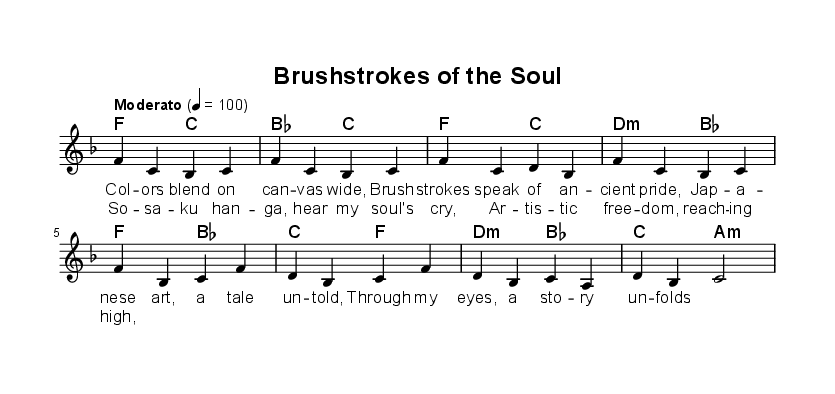what is the key signature of this music? The key signature indicated in the music is F major, which has one flat (B flat).
Answer: F major what is the time signature of this music? The time signature shown in the music is 4/4, indicating four beats per measure.
Answer: 4/4 what is the tempo marking of this piece? The tempo marking indicates "Moderato" at a speed of 100 beats per minute.
Answer: Moderato 100 how many measures are in the verse section? By examining the verse section, we see two measures, as seen in the melody and corresponding lyrics.
Answer: 2 what musical elements are expressed in the chorus? The chorus expresses themes of artistic freedom through specific lyrics and the harmonic progressions used.
Answer: Artistic freedom what is the relationship between the lyrics and the musical themes? The lyrics depict the essence of Japanese artistic expression while showcasing the cultural pride through the melody and harmonies.
Answer: Japanese artistic expression what is the primary emotional expression conveyed through the song? The song conveys a sense of pride and longing for artistic freedom, rooted in cultural identity.
Answer: Pride and longing 